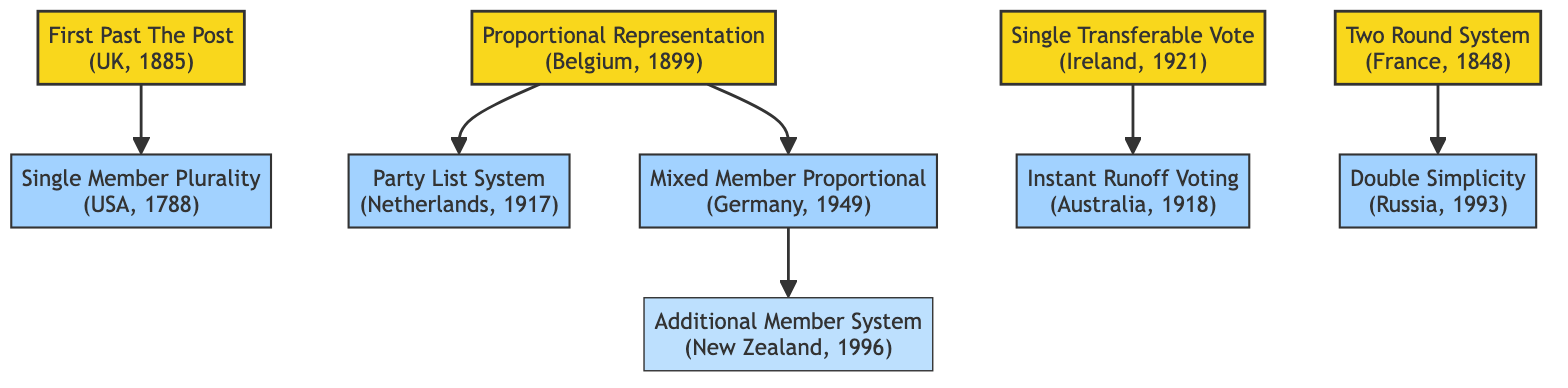What is the introduction year of First Past The Post? The diagram shows that First Past The Post is associated with the United Kingdom and was introduced in the year 1885. This information is directly indicated next to the node for First Past The Post.
Answer: 1885 Which voting system is a descendant of Proportional Representation? The diagram indicates that Proportional Representation has descendants, specifically the Party List System and Mixed Member Proportional. Both systems are connected to Proportional Representation as direct descendants.
Answer: Party List System, Mixed Member Proportional How many voting systems are shown in the diagram? By counting the distinct nodes that represent different voting systems, including the root and descendant nodes, we find a total of eight voting systems listed in the diagram.
Answer: 8 Which country uses the Instant Runoff Voting system? The diagram states that Australia is associated with the Instant Runoff Voting system, which indicates its use in that country. The connection is direct from the Single Transferable Vote node to the Instant Runoff Voting node.
Answer: Australia What is the relationship between the United States and Single Member Plurality? The diagram clearly shows that Single Member Plurality is a descendant of the First Past The Post system, which is used in the United Kingdom. The United States is specifically mentioned as using the Single Member Plurality system.
Answer: United States uses Single Member Plurality In what year did Ireland adopt the Single Transferable Vote? The diagram presents the information that Ireland introduced the Single Transferable Vote system in the year 1921, placing this specific detail next to the corresponding node for Single Transferable Vote.
Answer: 1921 Which voting system did Germany implement in 1949? The diagram explicitly states that Germany adopted the Mixed Member Proportional system in the year 1949, marked next to the relevant node. This reference indicates the specific system and its introduction year in Germany.
Answer: Mixed Member Proportional What is the country associated with the Double Simplicity voting system? By examining the diagram, we see that the Double Simplicity voting system is linked to Russia, as indicated in the descendant relationship from the Two Round System node down to Double Simplicity.
Answer: Russia 